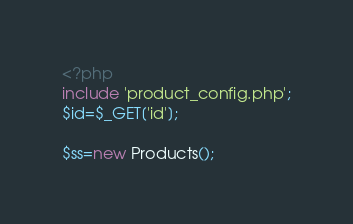<code> <loc_0><loc_0><loc_500><loc_500><_PHP_><?php
include 'product_config.php';
$id=$_GET['id'];

$ss=new Products();</code> 